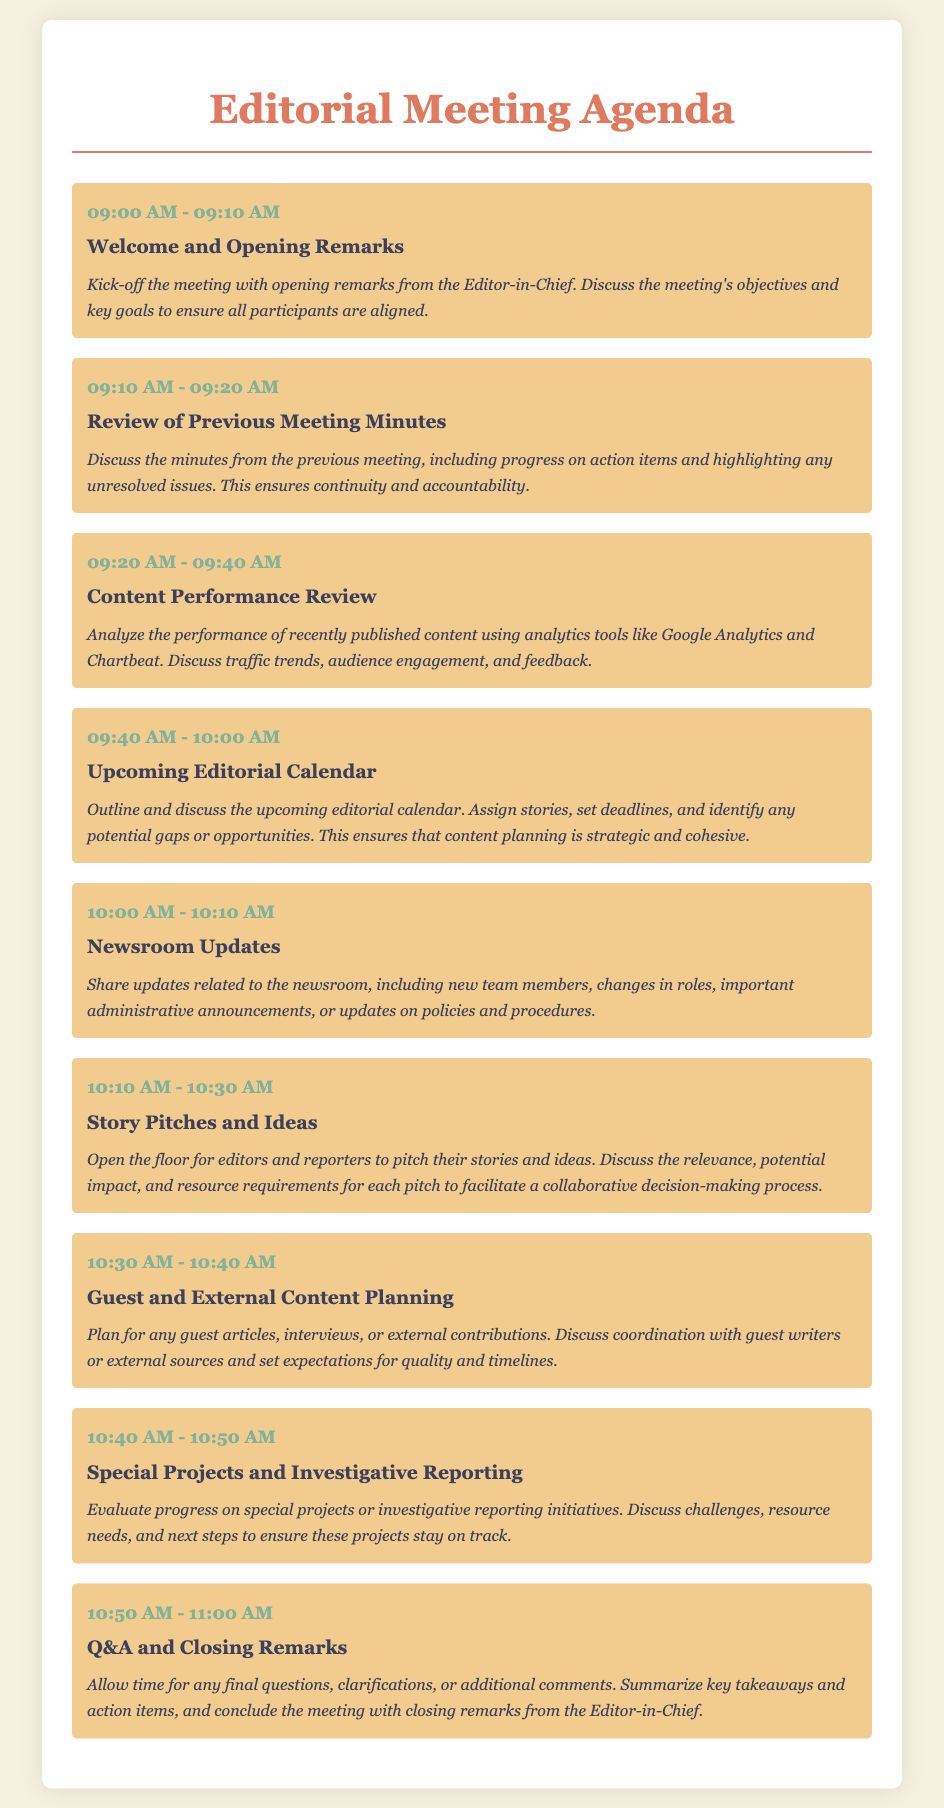What time does the meeting start? The meeting starts at 09:00 AM as indicated in the agenda.
Answer: 09:00 AM Who gives the opening remarks? The opening remarks are given by the Editor-in-Chief.
Answer: Editor-in-Chief How long is the content performance review? The content performance review lasts for 20 minutes according to the agenda.
Answer: 20 minutes What is discussed during the Q&A segment? The Q&A segment allows time for final questions, clarifications, or additional comments at the end of the meeting.
Answer: Final questions What is the purpose of reviewing previous meeting minutes? The purpose is to discuss progress on action items and highlight unresolved issues for continuity and accountability.
Answer: Continuity and accountability How many agenda items are scheduled for the meeting? There are a total of nine agenda items listed in the document.
Answer: Nine What is the scheduled time for the Newsroom Updates? The Newsroom Updates are scheduled from 10:00 AM to 10:10 AM.
Answer: 10:00 AM - 10:10 AM What activity is planned after story pitches? After story pitches, there is planning for guest and external content.
Answer: Guest and external content planning What is the last topic discussed before closing remarks? The last topic discussed before closing is Special Projects and Investigative Reporting.
Answer: Special Projects and Investigative Reporting 